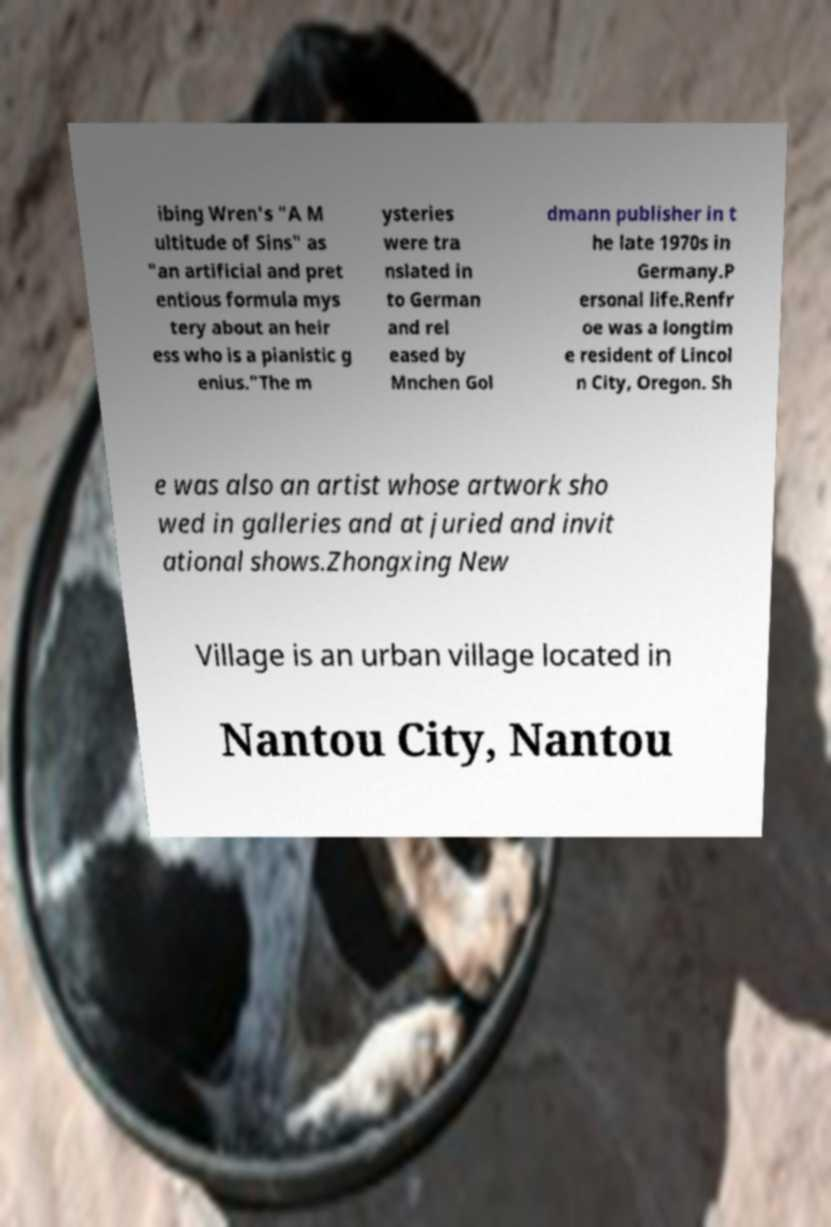There's text embedded in this image that I need extracted. Can you transcribe it verbatim? ibing Wren's "A M ultitude of Sins" as "an artificial and pret entious formula mys tery about an heir ess who is a pianistic g enius."The m ysteries were tra nslated in to German and rel eased by Mnchen Gol dmann publisher in t he late 1970s in Germany.P ersonal life.Renfr oe was a longtim e resident of Lincol n City, Oregon. Sh e was also an artist whose artwork sho wed in galleries and at juried and invit ational shows.Zhongxing New Village is an urban village located in Nantou City, Nantou 